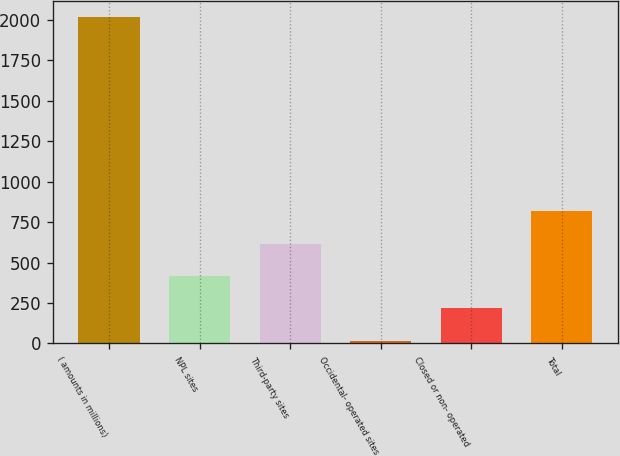<chart> <loc_0><loc_0><loc_500><loc_500><bar_chart><fcel>( amounts in millions)<fcel>NPL sites<fcel>Third-party sites<fcel>Occidental- operated sites<fcel>Closed or non- operated<fcel>Total<nl><fcel>2015<fcel>417.4<fcel>617.1<fcel>18<fcel>217.7<fcel>816.8<nl></chart> 